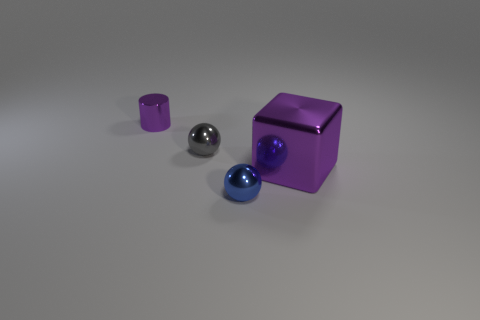What size is the other shiny object that is the same shape as the blue shiny thing?
Your answer should be very brief. Small. The shiny cube is what size?
Give a very brief answer. Large. Are there fewer objects behind the small cylinder than cylinders?
Your answer should be very brief. Yes. Do the blue metallic thing and the block have the same size?
Provide a succinct answer. No. Are there any other things that have the same size as the purple metal cylinder?
Give a very brief answer. Yes. There is a tiny cylinder that is the same material as the big purple object; what is its color?
Your answer should be very brief. Purple. Is the number of small metallic balls behind the purple block less than the number of tiny objects behind the tiny blue thing?
Ensure brevity in your answer.  Yes. What number of metallic blocks have the same color as the metallic cylinder?
Make the answer very short. 1. There is a tiny cylinder that is the same color as the shiny cube; what is its material?
Make the answer very short. Metal. How many things are behind the purple cube and on the right side of the tiny purple cylinder?
Keep it short and to the point. 1. 